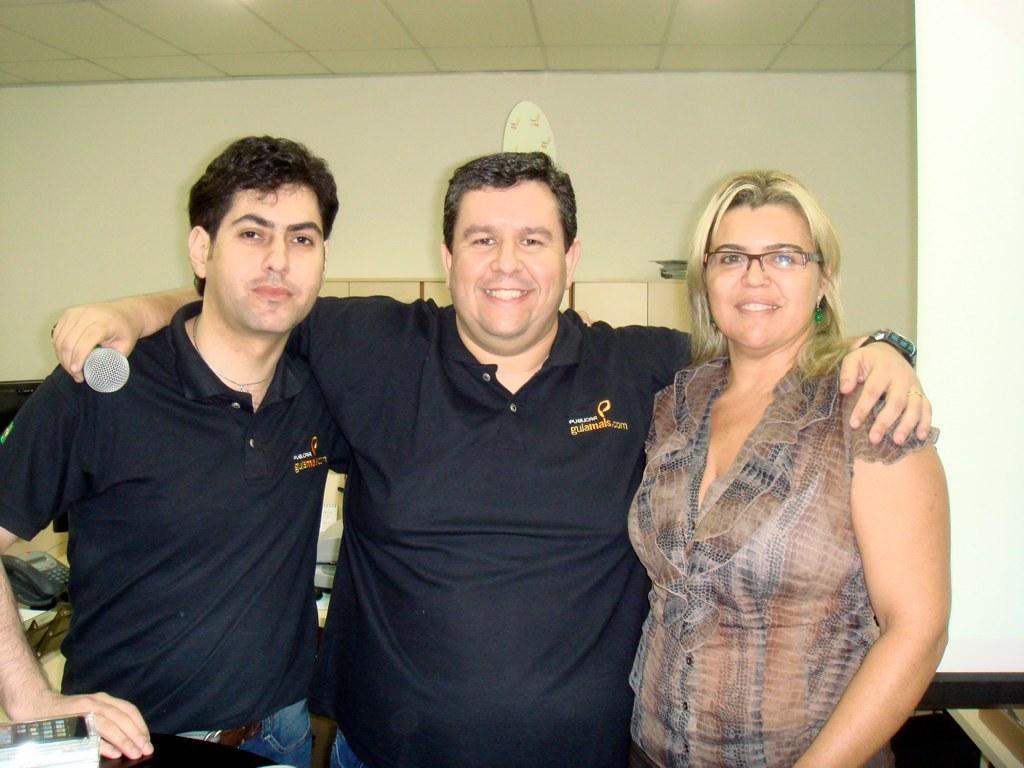Can you describe this image briefly? In this image we can see a group of people standing. One person is holding a microphone in his hand. On the left side of the image we can see an object placed on the table, a telephone placed on the surface. On the right side of the image we can see a projector screen. In the background, we can see an object on the wall and a file placed in the cupboard. 